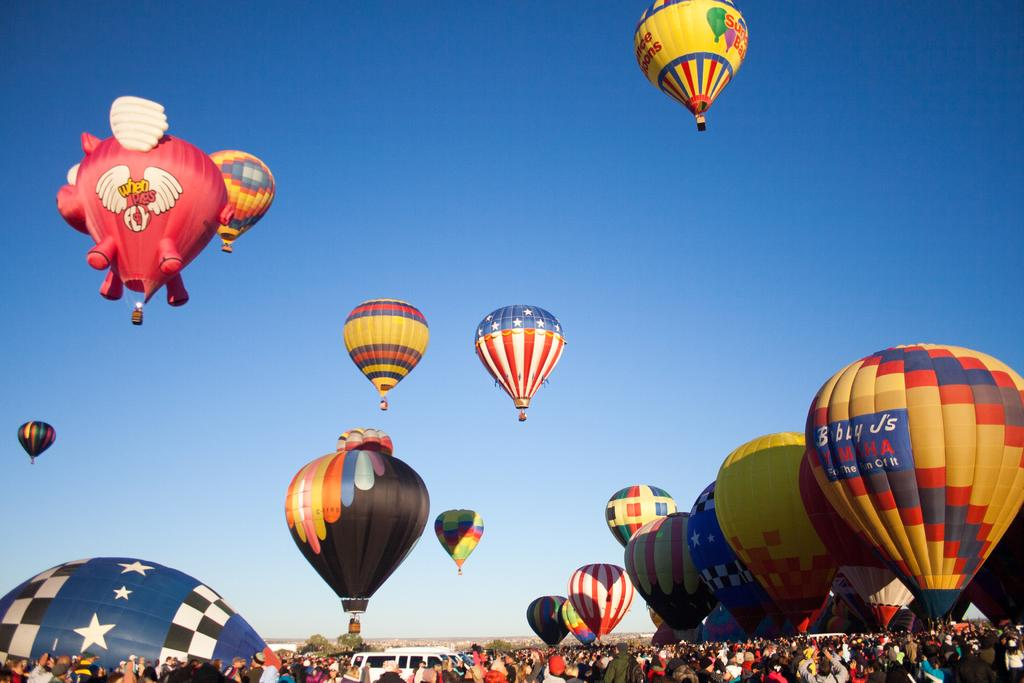<image>
Relay a brief, clear account of the picture shown. A hot air balloon has an advertisement for a Yamaha dealership on its multicolored exterior. 